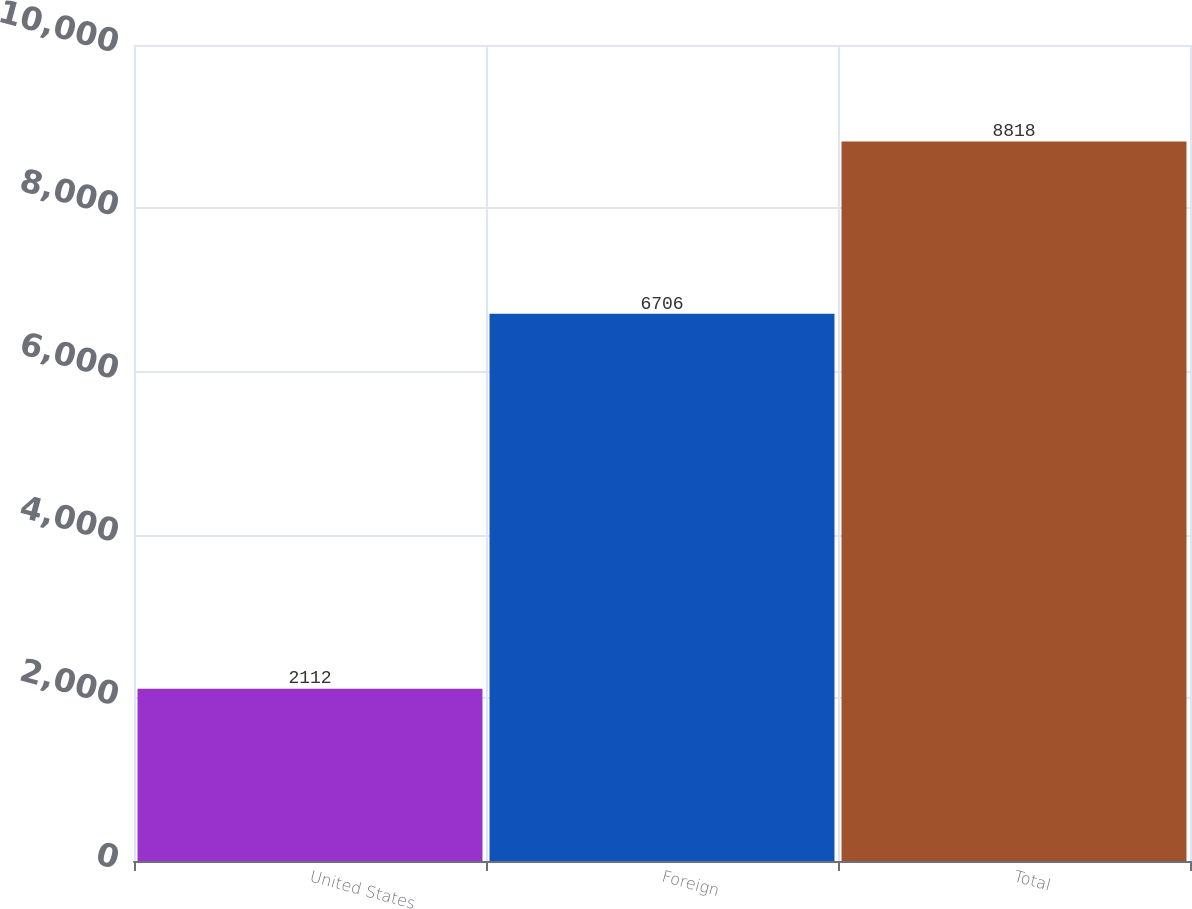Convert chart to OTSL. <chart><loc_0><loc_0><loc_500><loc_500><bar_chart><fcel>United States<fcel>Foreign<fcel>Total<nl><fcel>2112<fcel>6706<fcel>8818<nl></chart> 